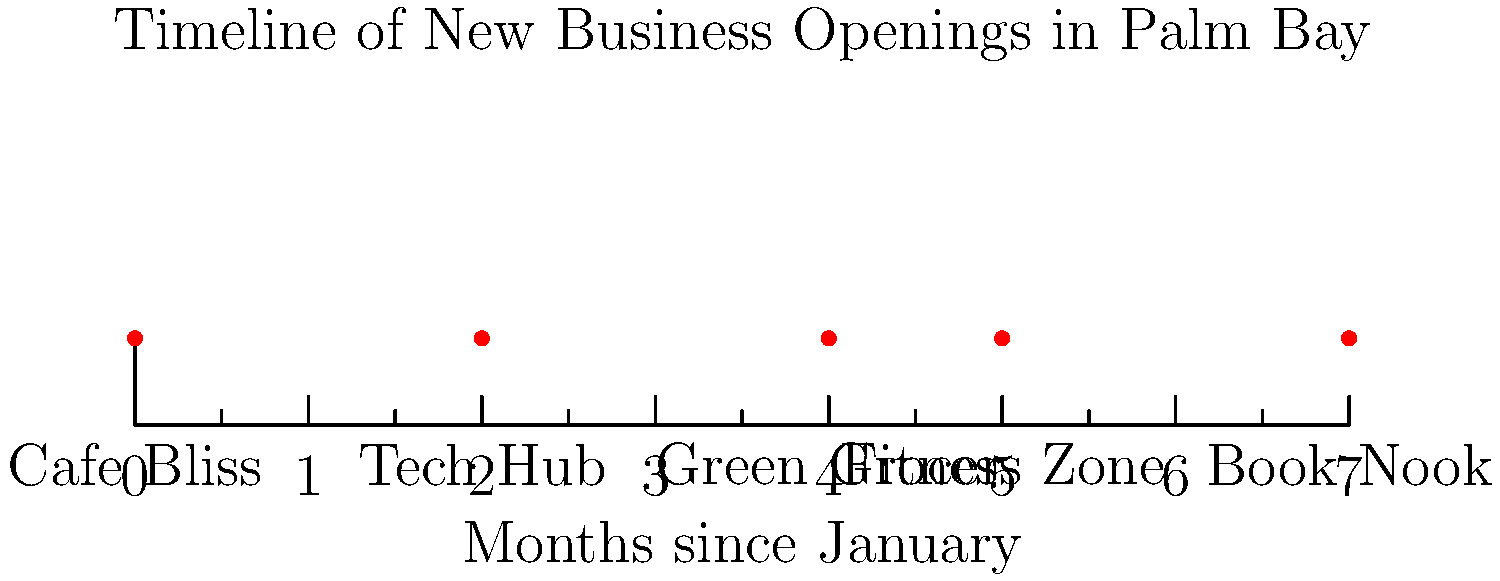Based on the timeline of new business openings in Palm Bay, what is the time difference in months between the opening of the first and last business? To find the time difference between the opening of the first and last business, we need to:

1. Identify the first business: Cafe Bliss, which opened at 0 months (January).
2. Identify the last business: Book Nook, which opened at 7 months.
3. Calculate the difference:
   $7 - 0 = 7$ months

The timeline shows the openings spread over 7 months, from January (0) to August (7).
Answer: 7 months 